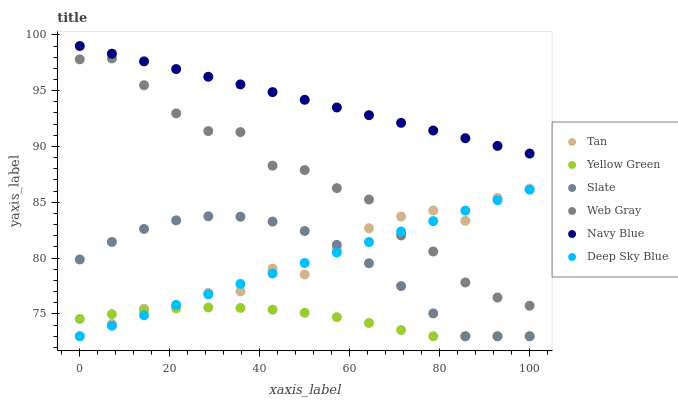Does Yellow Green have the minimum area under the curve?
Answer yes or no. Yes. Does Navy Blue have the maximum area under the curve?
Answer yes or no. Yes. Does Navy Blue have the minimum area under the curve?
Answer yes or no. No. Does Yellow Green have the maximum area under the curve?
Answer yes or no. No. Is Navy Blue the smoothest?
Answer yes or no. Yes. Is Web Gray the roughest?
Answer yes or no. Yes. Is Yellow Green the smoothest?
Answer yes or no. No. Is Yellow Green the roughest?
Answer yes or no. No. Does Yellow Green have the lowest value?
Answer yes or no. Yes. Does Navy Blue have the lowest value?
Answer yes or no. No. Does Navy Blue have the highest value?
Answer yes or no. Yes. Does Yellow Green have the highest value?
Answer yes or no. No. Is Yellow Green less than Navy Blue?
Answer yes or no. Yes. Is Navy Blue greater than Tan?
Answer yes or no. Yes. Does Slate intersect Yellow Green?
Answer yes or no. Yes. Is Slate less than Yellow Green?
Answer yes or no. No. Is Slate greater than Yellow Green?
Answer yes or no. No. Does Yellow Green intersect Navy Blue?
Answer yes or no. No. 